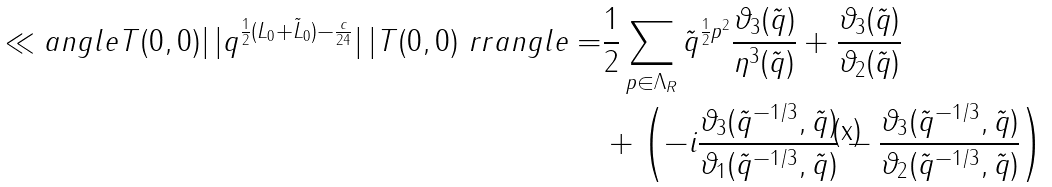Convert formula to latex. <formula><loc_0><loc_0><loc_500><loc_500>\ll a n g l e T ( 0 , 0 ) | \, | q ^ { \frac { 1 } { 2 } ( L _ { 0 } + \tilde { L } _ { 0 } ) - \frac { c } { 2 4 } } | \, | T ( 0 , 0 ) \ r r a n g l e = & \frac { 1 } { 2 } \sum _ { p \in \Lambda _ { R } } \tilde { q } ^ { \frac { 1 } { 2 } p ^ { 2 } } \frac { \vartheta _ { 3 } ( \tilde { q } ) } { \eta ^ { 3 } ( \tilde { q } ) } + \frac { \vartheta _ { 3 } ( \tilde { q } ) } { \vartheta _ { 2 } ( \tilde { q } ) } \\ & + \left ( - i \frac { \vartheta _ { 3 } ( \tilde { q } ^ { - 1 / 3 } , \tilde { q } ) } { \vartheta _ { 1 } ( \tilde { q } ^ { - 1 / 3 } , \tilde { q } ) } - \frac { \vartheta _ { 3 } ( \tilde { q } ^ { - 1 / 3 } , \tilde { q } ) } { \vartheta _ { 2 } ( \tilde { q } ^ { - 1 / 3 } , \tilde { q } ) } \right )</formula> 